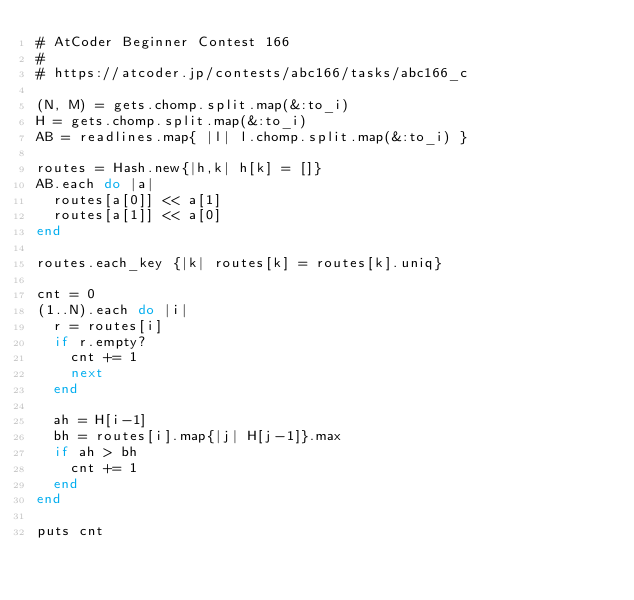<code> <loc_0><loc_0><loc_500><loc_500><_Ruby_># AtCoder Beginner Contest 166
# 
# https://atcoder.jp/contests/abc166/tasks/abc166_c

(N, M) = gets.chomp.split.map(&:to_i)
H = gets.chomp.split.map(&:to_i)
AB = readlines.map{ |l| l.chomp.split.map(&:to_i) }

routes = Hash.new{|h,k| h[k] = []}
AB.each do |a|
  routes[a[0]] << a[1]
  routes[a[1]] << a[0]
end

routes.each_key {|k| routes[k] = routes[k].uniq}

cnt = 0
(1..N).each do |i|
  r = routes[i]
  if r.empty?
    cnt += 1
    next
  end

  ah = H[i-1]
  bh = routes[i].map{|j| H[j-1]}.max
  if ah > bh
    cnt += 1
  end
end

puts cnt
</code> 